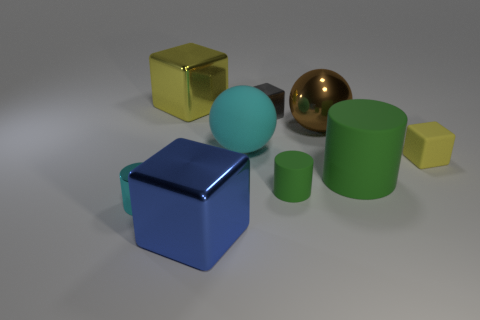Subtract all cyan balls. How many balls are left? 1 Subtract all rubber cylinders. How many cylinders are left? 1 Subtract all yellow spheres. Subtract all cyan cylinders. How many spheres are left? 2 Subtract all gray blocks. Subtract all small gray objects. How many objects are left? 7 Add 7 tiny yellow cubes. How many tiny yellow cubes are left? 8 Add 2 big yellow objects. How many big yellow objects exist? 3 Add 1 big yellow blocks. How many objects exist? 10 Subtract 1 cyan balls. How many objects are left? 8 Subtract all cylinders. How many objects are left? 6 Subtract 1 spheres. How many spheres are left? 1 